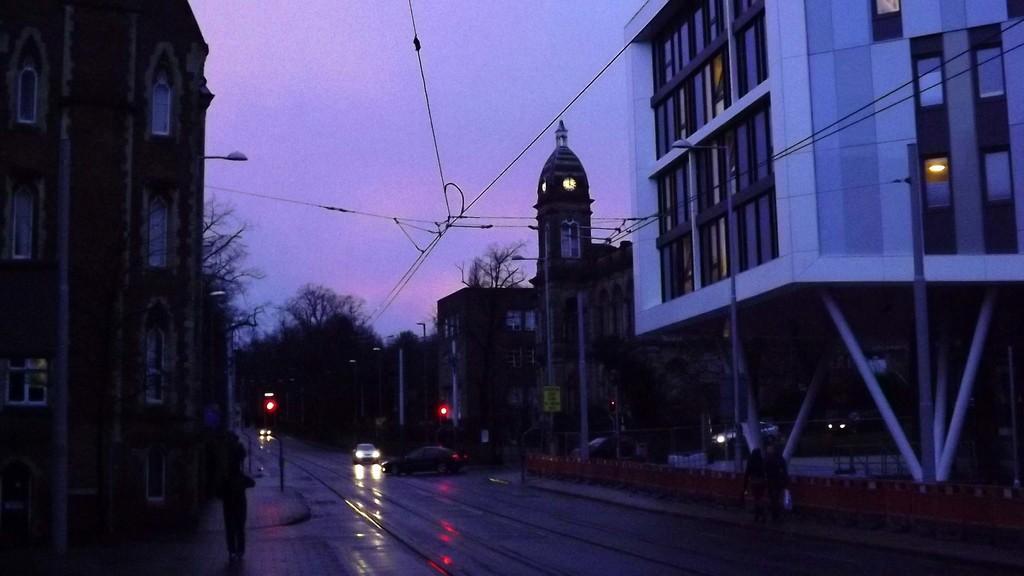Could you give a brief overview of what you see in this image? In the picture we can see a road on it, we can see two cars and on the other sides of the building we can see a path with poles and buildings and into the buildings we can see the windows with glasses and some trees near it and behind it we can see a sky. 